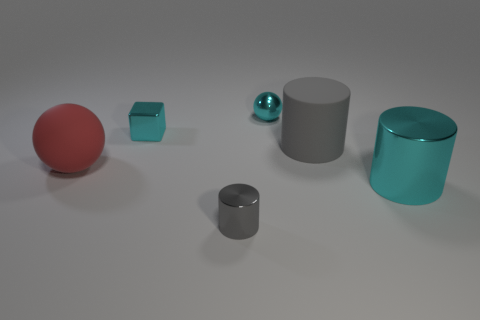What number of other things are the same color as the small cylinder?
Give a very brief answer. 1. What number of objects are either large objects to the right of the big ball or small things in front of the matte cylinder?
Provide a succinct answer. 3. How big is the matte object right of the rubber thing that is in front of the big rubber cylinder?
Give a very brief answer. Large. The shiny ball is what size?
Provide a short and direct response. Small. There is a sphere that is to the left of the cyan block; does it have the same color as the tiny metallic object that is left of the small gray metallic cylinder?
Ensure brevity in your answer.  No. What number of other things are the same material as the big gray object?
Provide a short and direct response. 1. Is there a tiny rubber ball?
Provide a short and direct response. No. Is the material of the red thing that is behind the big cyan thing the same as the small block?
Give a very brief answer. No. There is another gray object that is the same shape as the small gray thing; what is its material?
Your answer should be very brief. Rubber. What is the material of the small cube that is the same color as the tiny ball?
Offer a terse response. Metal. 